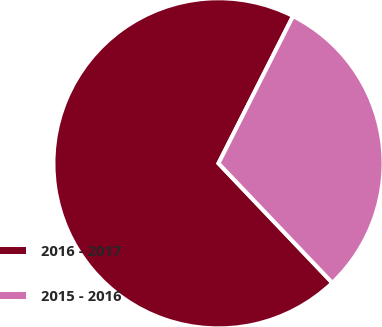Convert chart to OTSL. <chart><loc_0><loc_0><loc_500><loc_500><pie_chart><fcel>2016 - 2017<fcel>2015 - 2016<nl><fcel>69.57%<fcel>30.43%<nl></chart> 